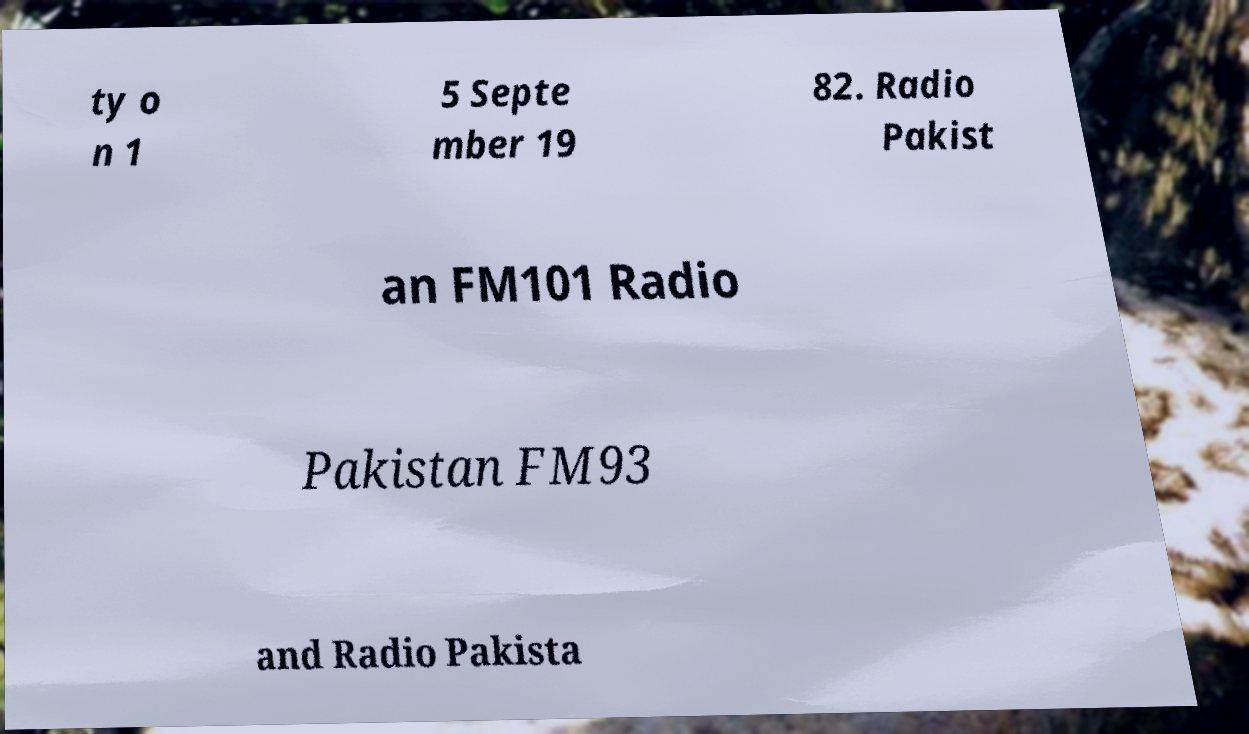Could you assist in decoding the text presented in this image and type it out clearly? ty o n 1 5 Septe mber 19 82. Radio Pakist an FM101 Radio Pakistan FM93 and Radio Pakista 